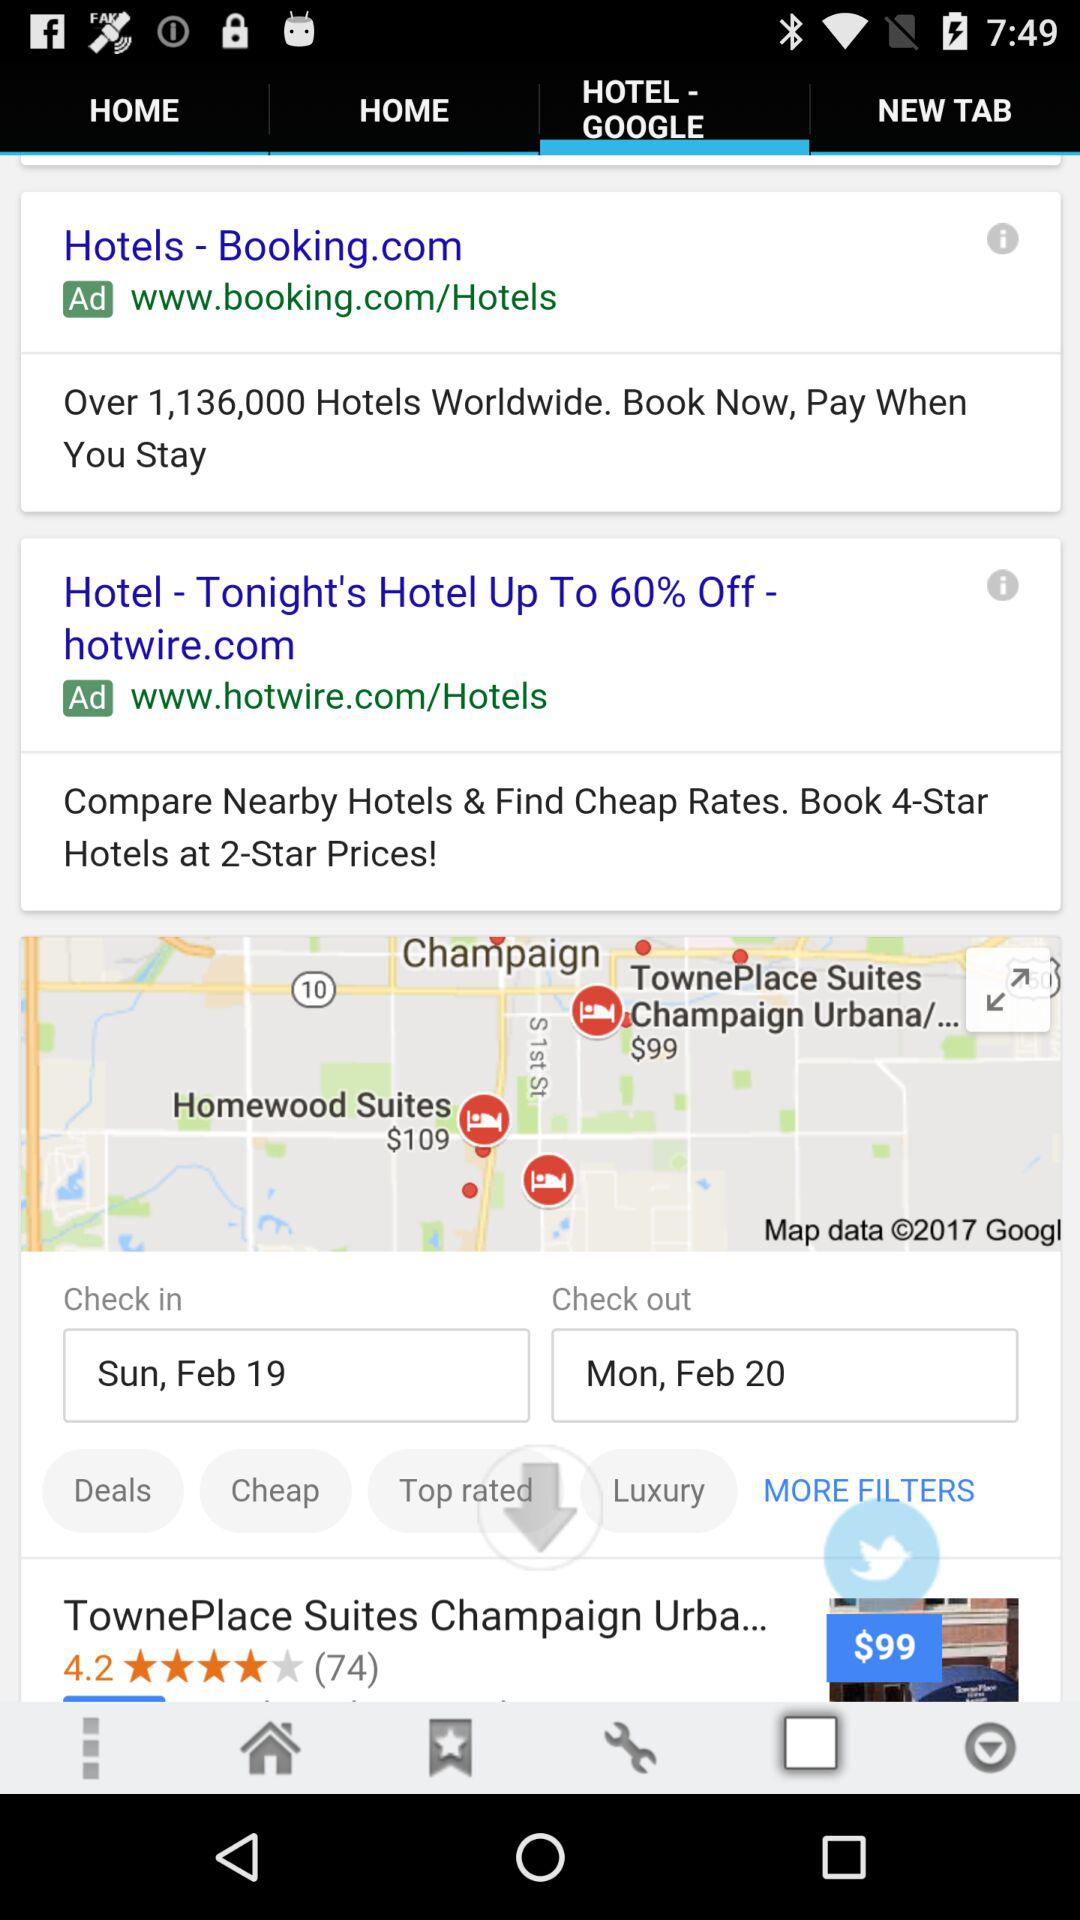What is the rating given on the screen? The rating given on the screen is 4.2. 